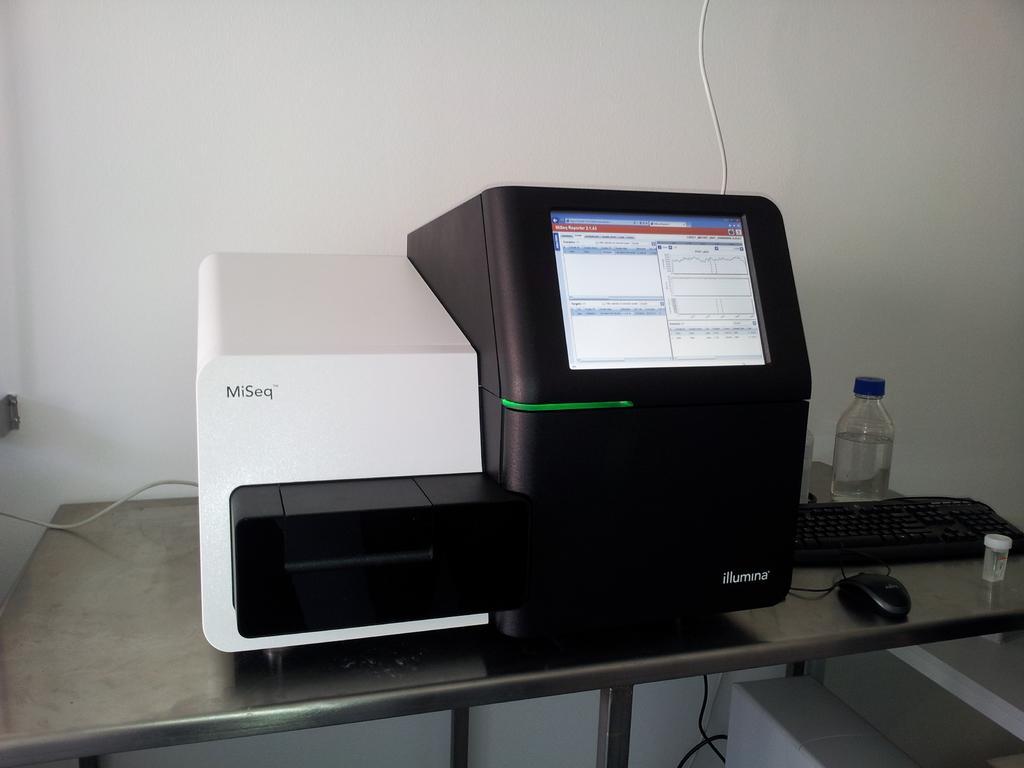How would you summarize this image in a sentence or two? In this picture we can see a machine, bottle, keyboard and a mouse on the table, and also we can see a wall. 